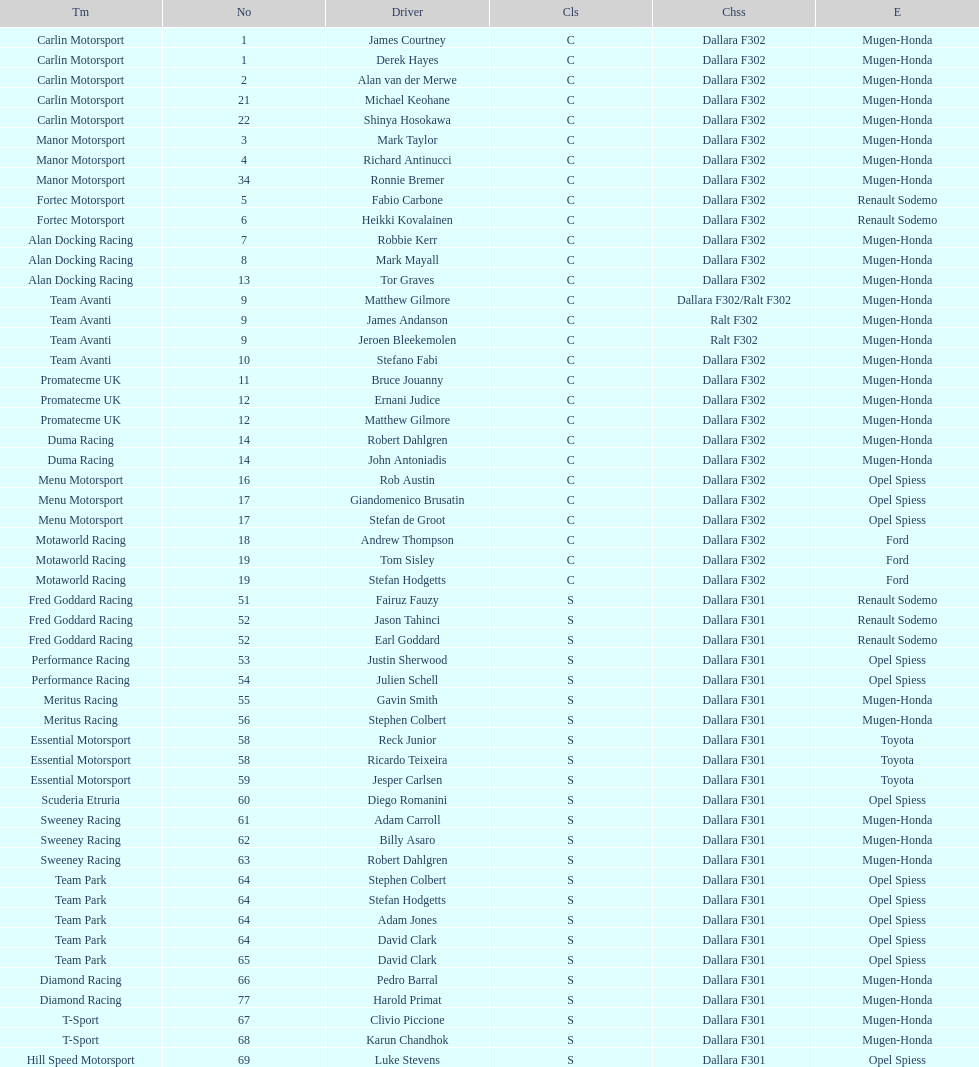Who had more drivers, team avanti or motaworld racing? Team Avanti. 